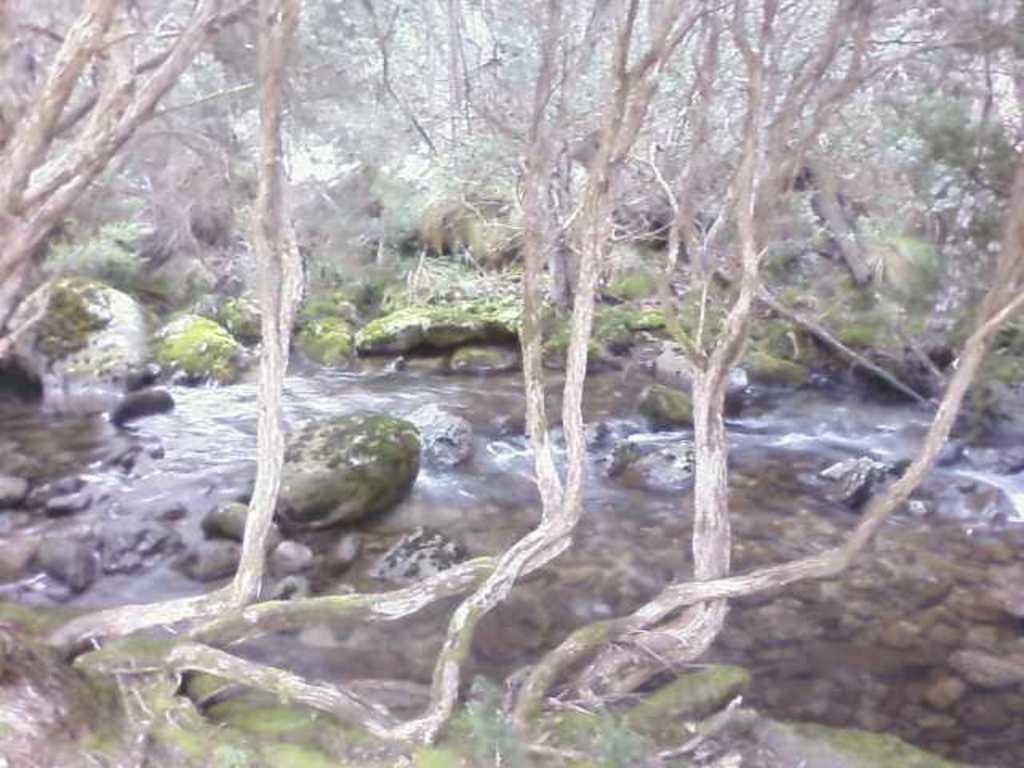What is happening in the image? There is a water flow in the image. Where is the water flow located? The water flow is in a forest area. What can be seen near the water flow? Stones and rocks are present near the water flow. How many robins can be seen sitting on the rocks near the water flow? There are no robins present in the image; it only features a water flow in a forest area with stones and rocks. 